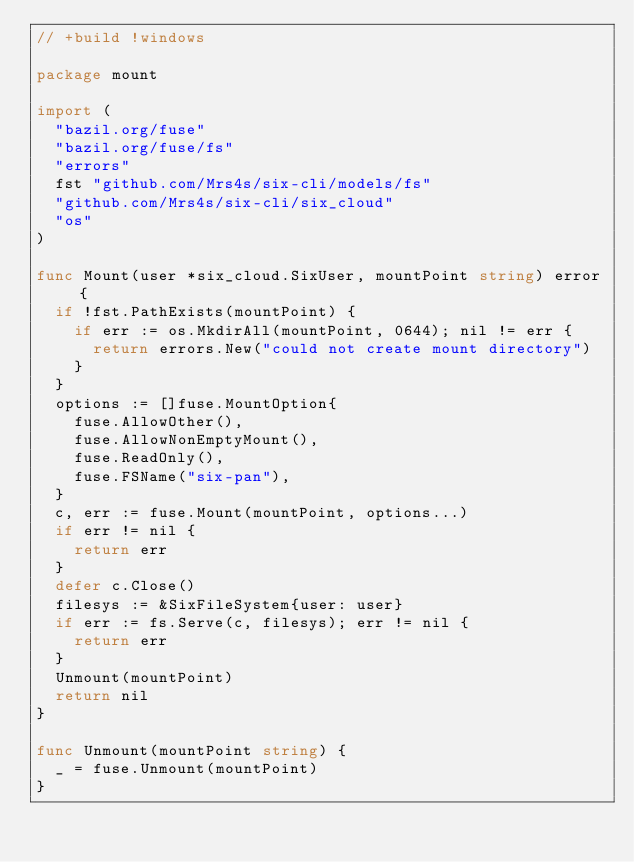<code> <loc_0><loc_0><loc_500><loc_500><_Go_>// +build !windows

package mount

import (
	"bazil.org/fuse"
	"bazil.org/fuse/fs"
	"errors"
	fst "github.com/Mrs4s/six-cli/models/fs"
	"github.com/Mrs4s/six-cli/six_cloud"
	"os"
)

func Mount(user *six_cloud.SixUser, mountPoint string) error {
	if !fst.PathExists(mountPoint) {
		if err := os.MkdirAll(mountPoint, 0644); nil != err {
			return errors.New("could not create mount directory")
		}
	}
	options := []fuse.MountOption{
		fuse.AllowOther(),
		fuse.AllowNonEmptyMount(),
		fuse.ReadOnly(),
		fuse.FSName("six-pan"),
	}
	c, err := fuse.Mount(mountPoint, options...)
	if err != nil {
		return err
	}
	defer c.Close()
	filesys := &SixFileSystem{user: user}
	if err := fs.Serve(c, filesys); err != nil {
		return err
	}
	Unmount(mountPoint)
	return nil
}

func Unmount(mountPoint string) {
	_ = fuse.Unmount(mountPoint)
}
</code> 